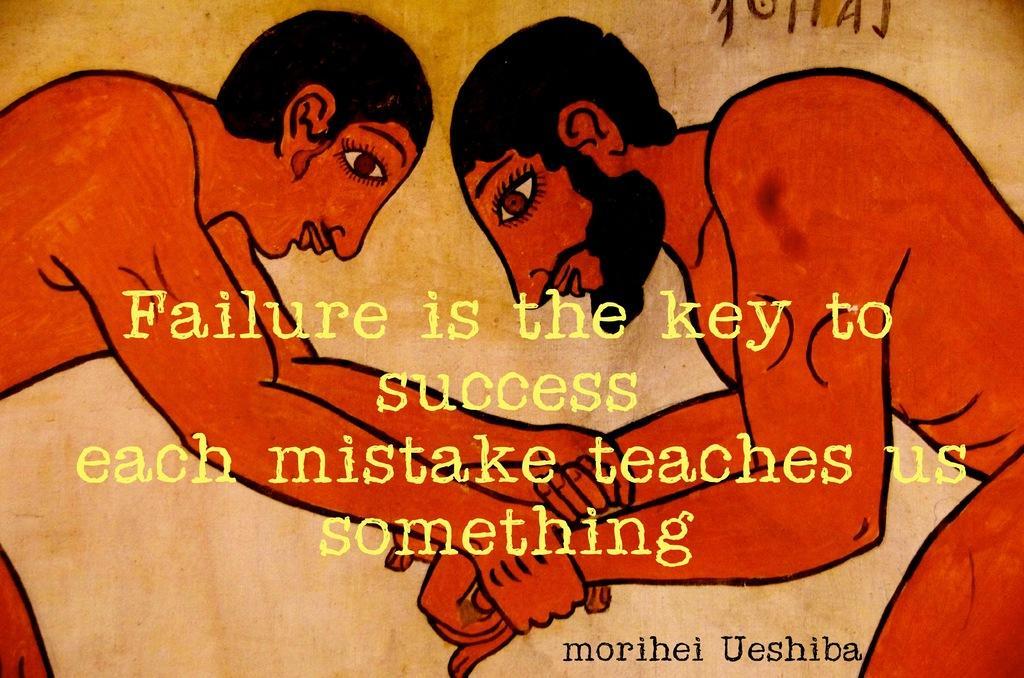Please provide a concise description of this image. In this image, there is an art contains persons and some text. 